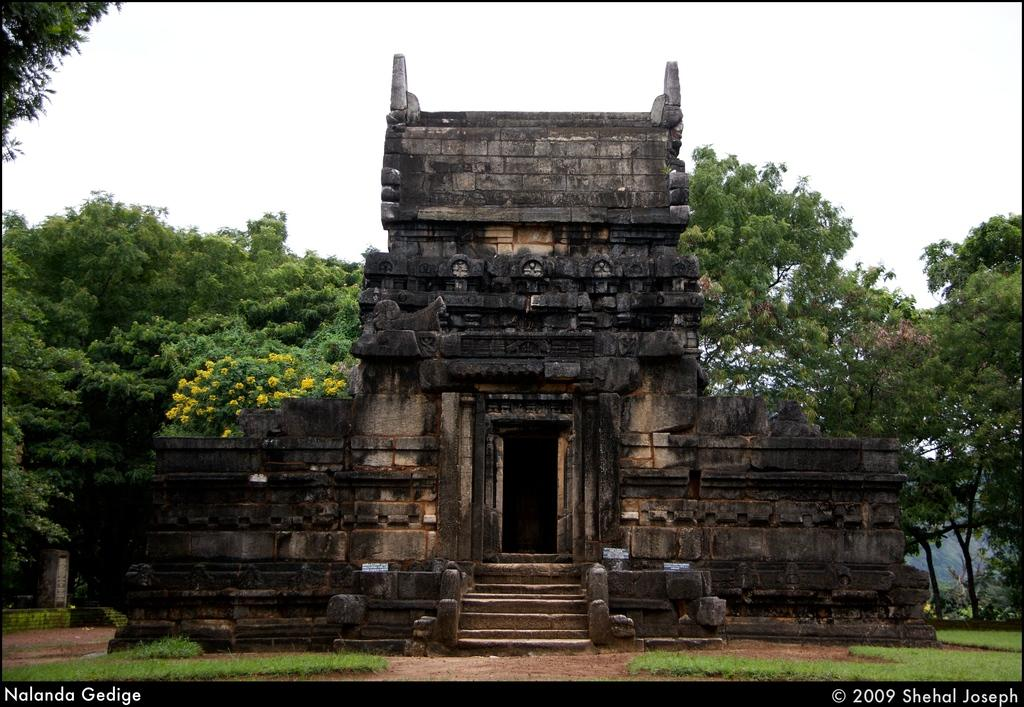What type of building is in the image? There is a stone building in the image. What architectural feature can be seen in the image? There are stairs in the image. What type of vegetation is present in the image? Grass and trees are visible in the image. What is the color of the sky in the image? The sky is white in the image. Are there any watermarks on the image? Yes, there is a watermark on the right and left, bottom of the image. How many zebras can be seen grazing on the grass in the image? There are no zebras present in the image; it features a stone building, stairs, grass, trees, and a white sky. 